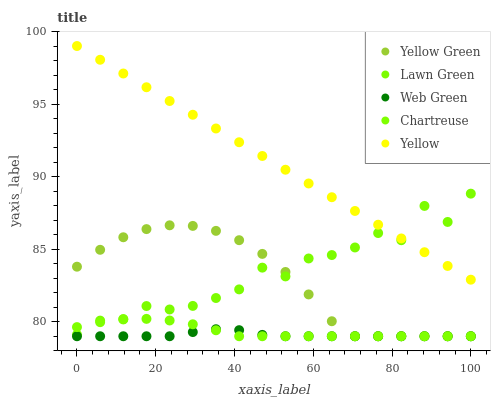Does Web Green have the minimum area under the curve?
Answer yes or no. Yes. Does Yellow have the maximum area under the curve?
Answer yes or no. Yes. Does Chartreuse have the minimum area under the curve?
Answer yes or no. No. Does Chartreuse have the maximum area under the curve?
Answer yes or no. No. Is Yellow the smoothest?
Answer yes or no. Yes. Is Lawn Green the roughest?
Answer yes or no. Yes. Is Chartreuse the smoothest?
Answer yes or no. No. Is Chartreuse the roughest?
Answer yes or no. No. Does Chartreuse have the lowest value?
Answer yes or no. Yes. Does Yellow have the lowest value?
Answer yes or no. No. Does Yellow have the highest value?
Answer yes or no. Yes. Does Chartreuse have the highest value?
Answer yes or no. No. Is Yellow Green less than Yellow?
Answer yes or no. Yes. Is Yellow greater than Web Green?
Answer yes or no. Yes. Does Yellow intersect Lawn Green?
Answer yes or no. Yes. Is Yellow less than Lawn Green?
Answer yes or no. No. Is Yellow greater than Lawn Green?
Answer yes or no. No. Does Yellow Green intersect Yellow?
Answer yes or no. No. 